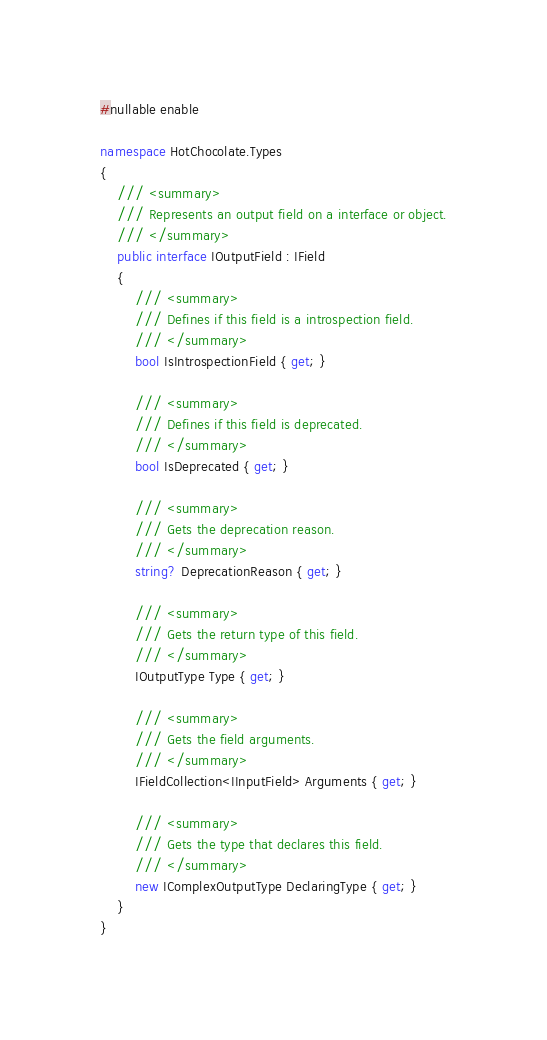Convert code to text. <code><loc_0><loc_0><loc_500><loc_500><_C#_>#nullable enable

namespace HotChocolate.Types
{
    /// <summary>
    /// Represents an output field on a interface or object.
    /// </summary>
    public interface IOutputField : IField
    {
        /// <summary>
        /// Defines if this field is a introspection field.
        /// </summary>
        bool IsIntrospectionField { get; }

        /// <summary>
        /// Defines if this field is deprecated.
        /// </summary>
        bool IsDeprecated { get; }

        /// <summary>
        /// Gets the deprecation reason.
        /// </summary>
        string? DeprecationReason { get; }

        /// <summary>
        /// Gets the return type of this field.
        /// </summary>
        IOutputType Type { get; }

        /// <summary>
        /// Gets the field arguments.
        /// </summary>
        IFieldCollection<IInputField> Arguments { get; }

        /// <summary>
        /// Gets the type that declares this field.
        /// </summary>
        new IComplexOutputType DeclaringType { get; }
    }
}
</code> 